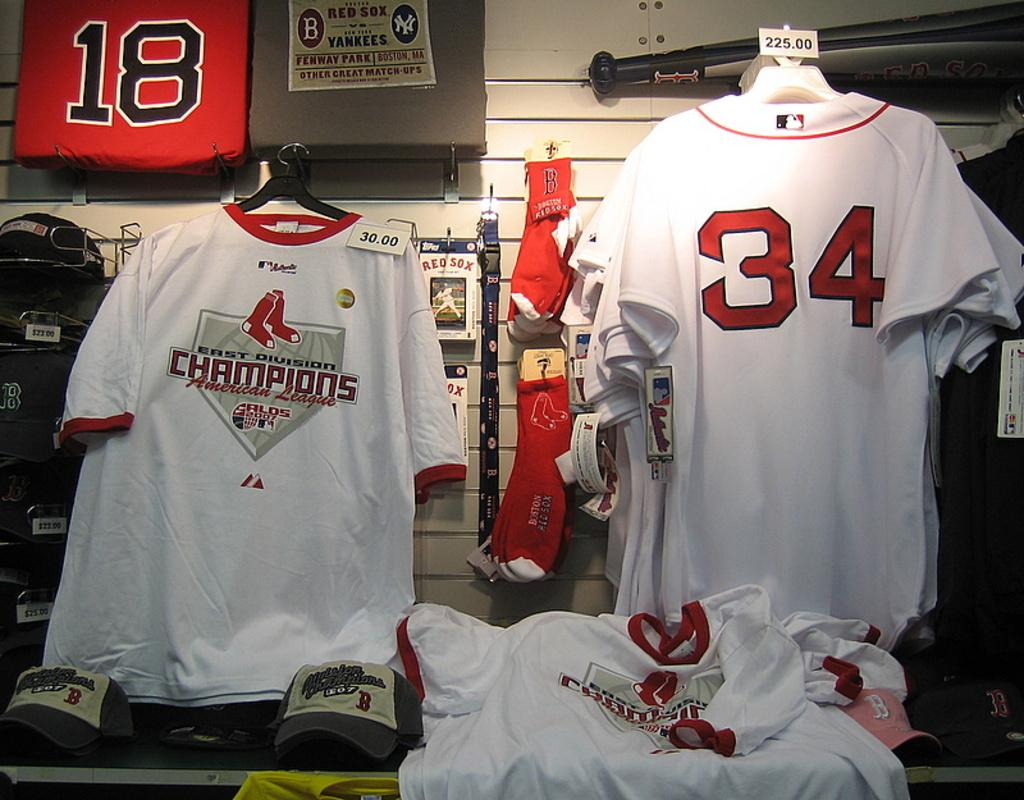<image>
Share a concise interpretation of the image provided. white shirts and jerseys with the number 34 on it 